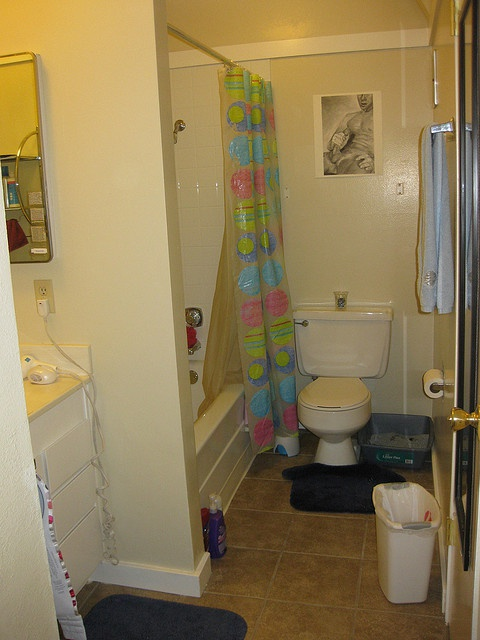Describe the objects in this image and their specific colors. I can see toilet in orange and gray tones and hair drier in orange and tan tones in this image. 